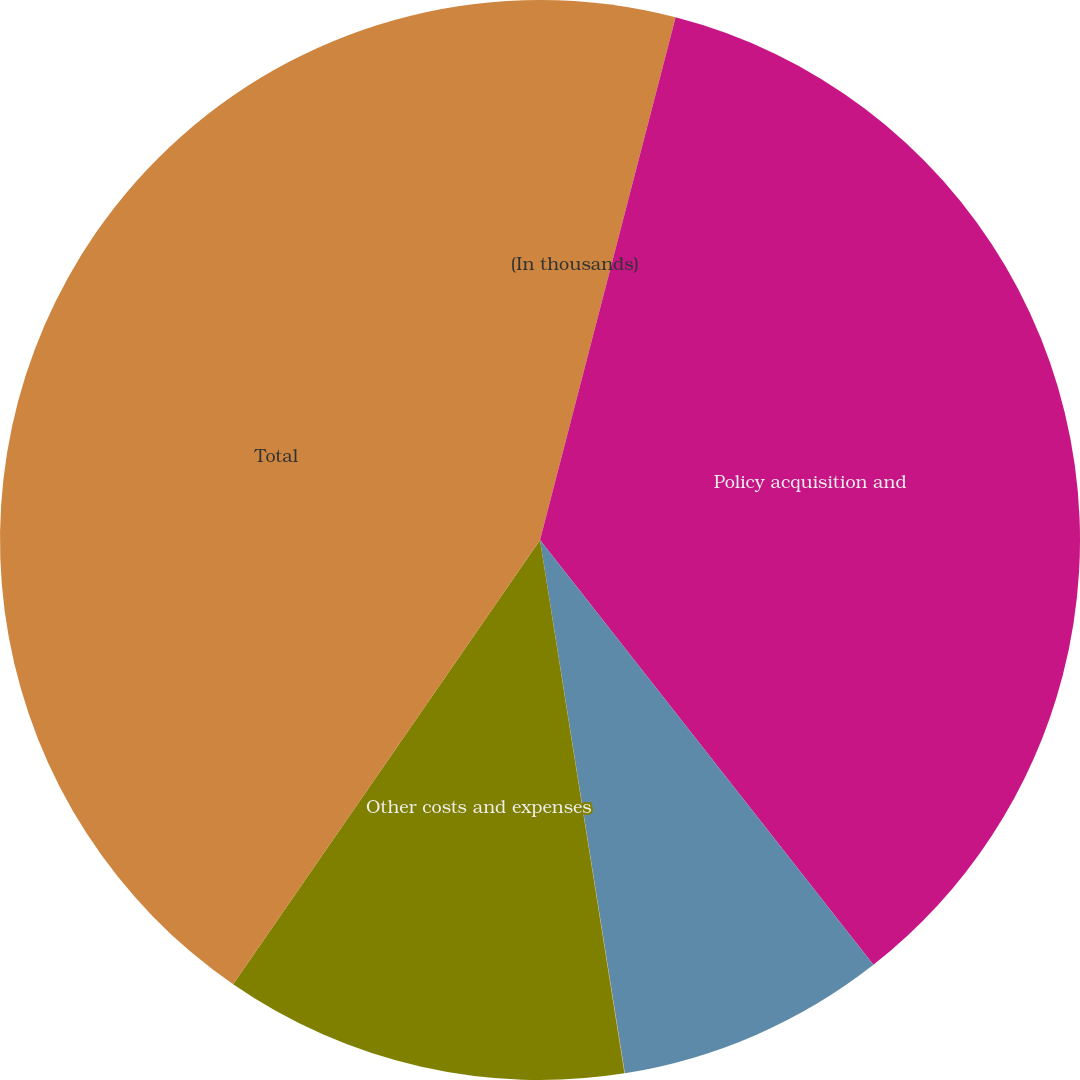Convert chart to OTSL. <chart><loc_0><loc_0><loc_500><loc_500><pie_chart><fcel>(In thousands)<fcel>Policy acquisition and<fcel>Service expenses<fcel>Net foreign currency (gains)<fcel>Other costs and expenses<fcel>Total<nl><fcel>4.04%<fcel>35.37%<fcel>8.08%<fcel>0.01%<fcel>12.12%<fcel>40.38%<nl></chart> 